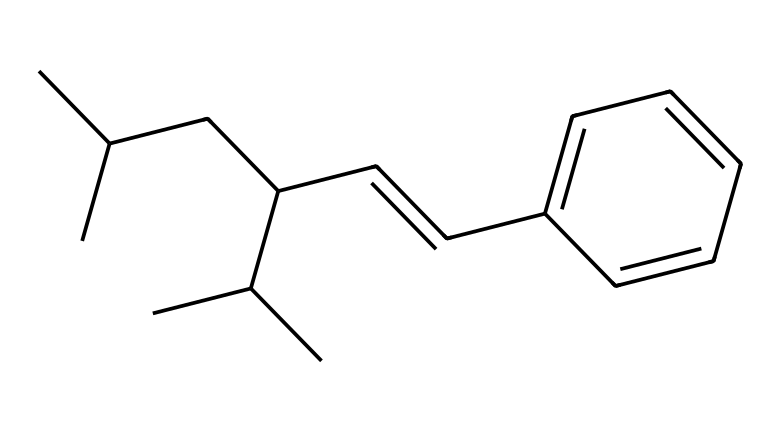What is the total number of carbon atoms in this polymer structure? By analyzing the SMILES representation, we can count the carbon atoms represented. In the given structure, each "C" corresponds to a carbon atom. Counting them gives us a total of 20 carbon atoms.
Answer: 20 What type of structure is represented in this SMILES notation? The presence of long carbon chains and the nature of the branching suggest that it is a polymer. Specifically, it represents a synthetic rubber used in tires, known for its elasticity and durability.
Answer: polymer What is the degree of unsaturation in this compound? The chemical structure contains a double bond and rings. The degree of unsaturation can typically be determined from the number of double bonds and rings in the compound. Given the presence of one double bond and no rings in the structure, the degree of unsaturation is 1.
Answer: 1 How many hydrogen atoms are directly associated with the longest carbon chain? The longest carbon chain can be identified from the structure, and then the associated hydrogen atoms can be counted. In the given SMILES, the longest chain is identified, and it shows that it is saturated with hydrogen atoms except for the double bonds. Counting these, we find there are 34 hydrogen atoms.
Answer: 34 What is the significance of the branching in this polymer? The branching in the polymer structure influences its physical properties. Specifically, it contributes to the material's flexibility and strength, making it suitable for use in car tires. The branched structure complicates the packing of the polymer chains, impacting the tire's performance.
Answer: flexibility What is the primary use of this type of synthetic rubber? This type of synthetic rubber is primarily used in the manufacturing of tires. It is chosen for its excellent durability, resistance to wear, and ability to provide grip on various surfaces, which is essential for vehicle performance and safety.
Answer: tires 